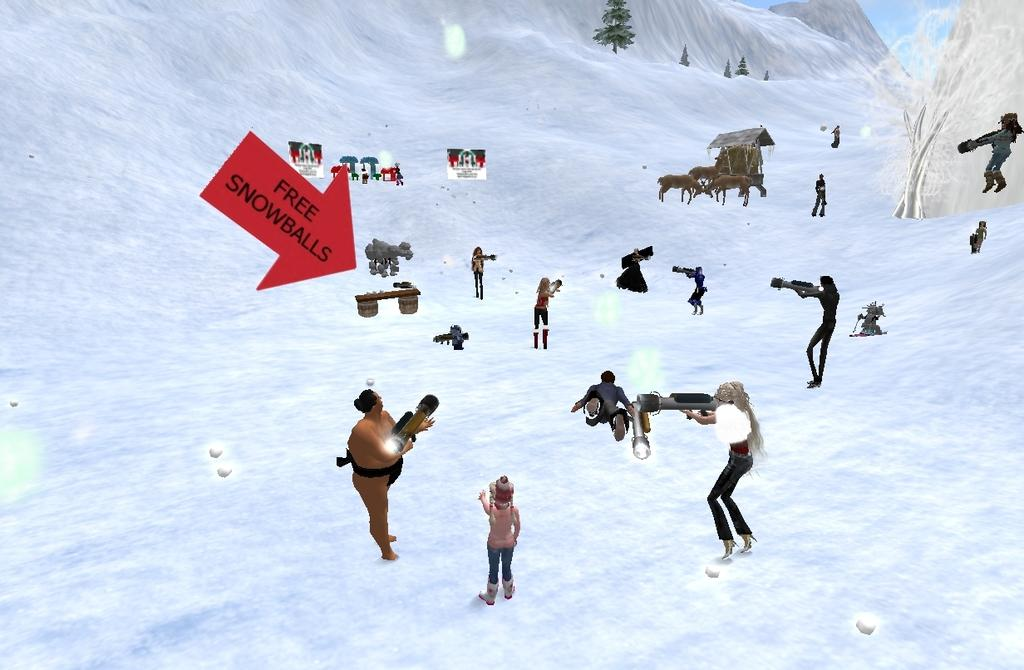What type of content is featured in the image? The image contains an animation. Can you describe the characters in the animation? There are people and animals in the animation. What type of environment is depicted in the animation? There are trees present in the animation, and it is snowing. What color is the hair of the animals in the image? There are no animals with hair present in the image, as the animals depicted are likely furry or feathered. 